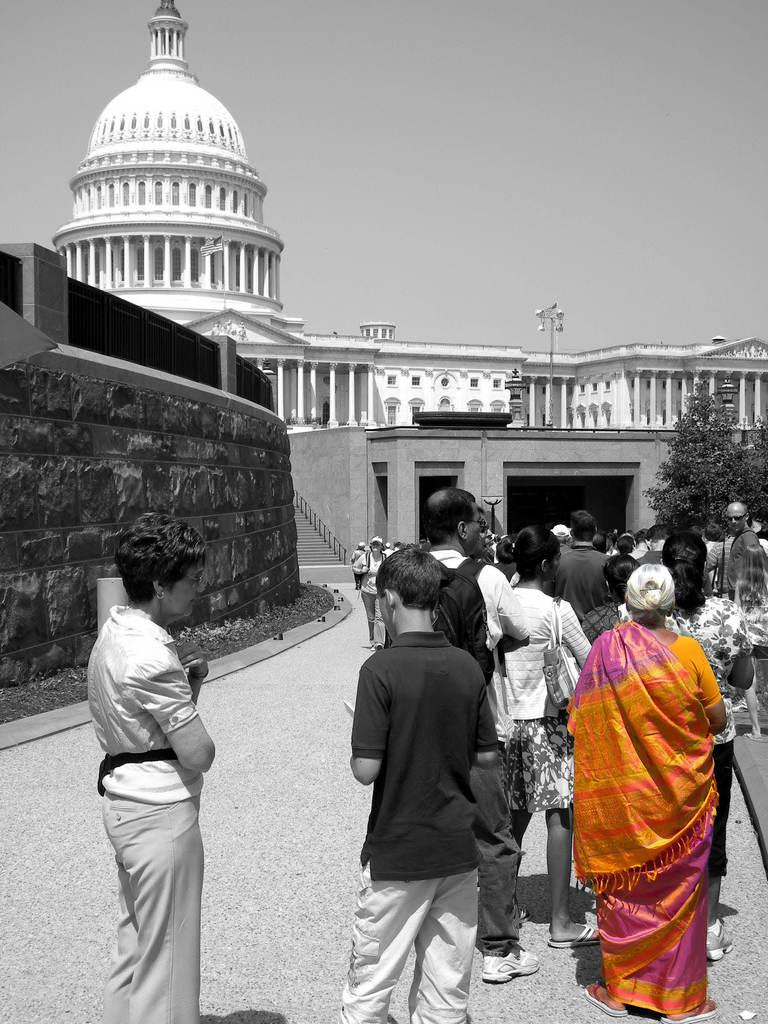What type of structure is visible in the image? There is a building in the image. What material is used for the wall in the image? There is a brick wall in the image. What type of vegetation can be seen in the image? There are trees and grass in the image. What architectural feature is present in the image? There are stairs in the image. What is the surface that vehicles might travel on in the image? There is a road in the image. Are there any people visible in the image? Yes, there are people standing in the image. What part of the natural environment is visible in the image? The sky is visible in the image. Can you tell me how many dogs are sitting on the grass in the image? There are no dogs present in the image; it features a building, a brick wall, trees, grass, stairs, a road, people, and the sky. What type of pain is the person experiencing in the image? There is no indication of pain or any health-related issues in the image. 